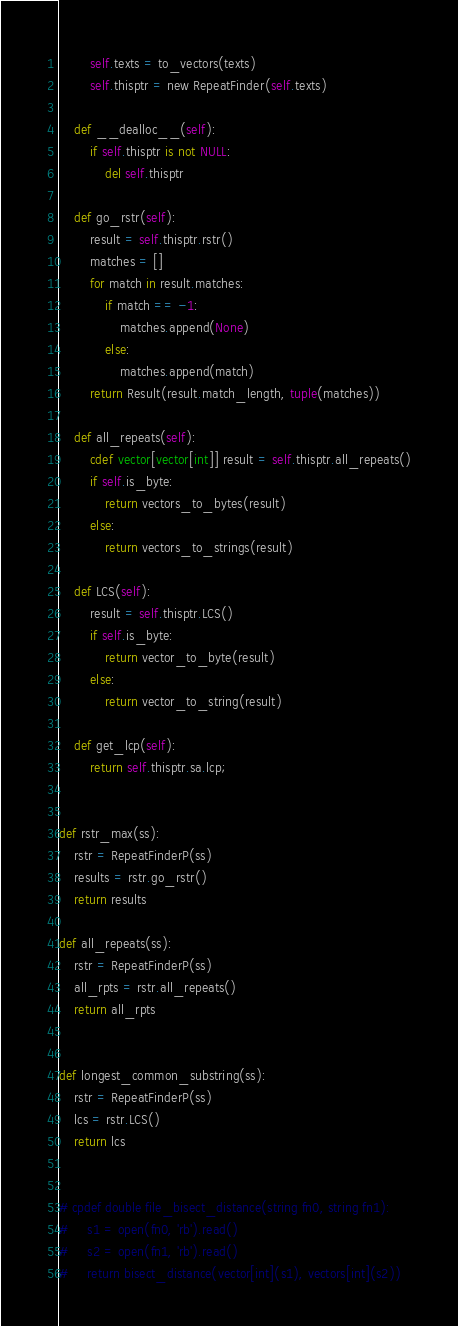Convert code to text. <code><loc_0><loc_0><loc_500><loc_500><_Cython_>        self.texts = to_vectors(texts)
        self.thisptr = new RepeatFinder(self.texts)

    def __dealloc__(self):
        if self.thisptr is not NULL:
            del self.thisptr

    def go_rstr(self):
        result = self.thisptr.rstr()
        matches = []
        for match in result.matches:
            if match == -1:
                matches.append(None)
            else:
                matches.append(match)
        return Result(result.match_length, tuple(matches))

    def all_repeats(self):
        cdef vector[vector[int]] result = self.thisptr.all_repeats()
        if self.is_byte:
            return vectors_to_bytes(result)
        else:
            return vectors_to_strings(result)

    def LCS(self):
        result = self.thisptr.LCS()
        if self.is_byte:
            return vector_to_byte(result)
        else:
            return vector_to_string(result)

    def get_lcp(self):
        return self.thisptr.sa.lcp;


def rstr_max(ss):
    rstr = RepeatFinderP(ss)
    results = rstr.go_rstr()
    return results

def all_repeats(ss):
    rstr = RepeatFinderP(ss)
    all_rpts = rstr.all_repeats()
    return all_rpts


def longest_common_substring(ss):
    rstr = RepeatFinderP(ss)
    lcs = rstr.LCS()
    return lcs


# cpdef double file_bisect_distance(string fn0, string fn1):
#     s1 = open(fn0, 'rb').read()
#     s2 = open(fn1, 'rb').read()
#     return bisect_distance(vector[int](s1), vectors[int](s2))
</code> 